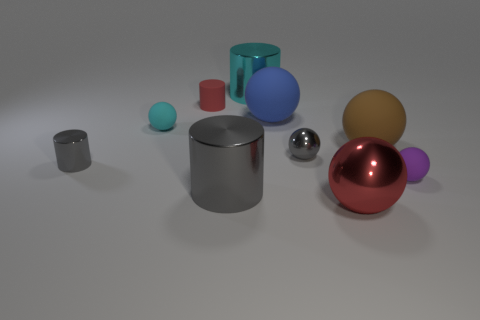Subtract 3 spheres. How many spheres are left? 3 Subtract all red spheres. How many spheres are left? 5 Subtract all red shiny balls. How many balls are left? 5 Subtract all yellow spheres. Subtract all brown blocks. How many spheres are left? 6 Subtract all cylinders. How many objects are left? 6 Subtract all large metal balls. Subtract all brown matte objects. How many objects are left? 8 Add 2 blue balls. How many blue balls are left? 3 Add 4 gray metallic spheres. How many gray metallic spheres exist? 5 Subtract 0 purple cylinders. How many objects are left? 10 